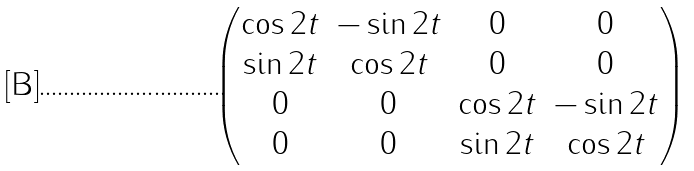Convert formula to latex. <formula><loc_0><loc_0><loc_500><loc_500>\begin{pmatrix} \cos 2 t & - \sin 2 t & 0 & 0 \\ \sin 2 t & \cos 2 t & 0 & 0 \\ 0 & 0 & \cos 2 t & - \sin 2 t \\ 0 & 0 & \sin 2 t & \cos 2 t \end{pmatrix}</formula> 